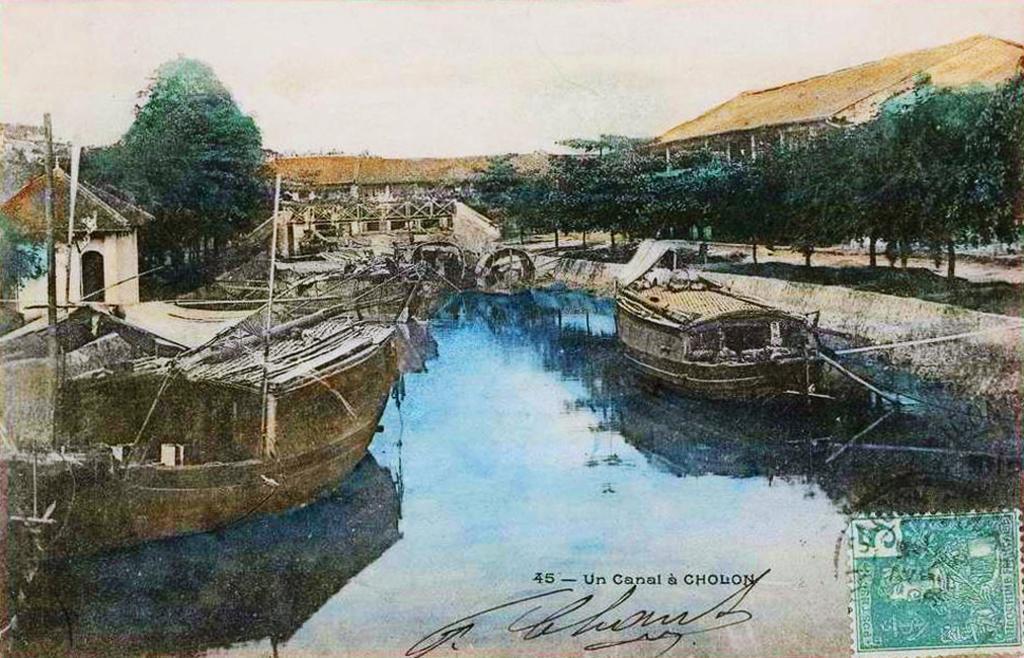Describe this image in one or two sentences. This image consists of a poster. In which we can see the boats in the water. On the right, there is a stamp. In the background, there are trees along with the houses. At the top, there is sky. At the top, there is sky. 